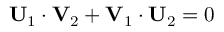<formula> <loc_0><loc_0><loc_500><loc_500>U _ { 1 } \cdot V _ { 2 } + V _ { 1 } \cdot U _ { 2 } = 0</formula> 